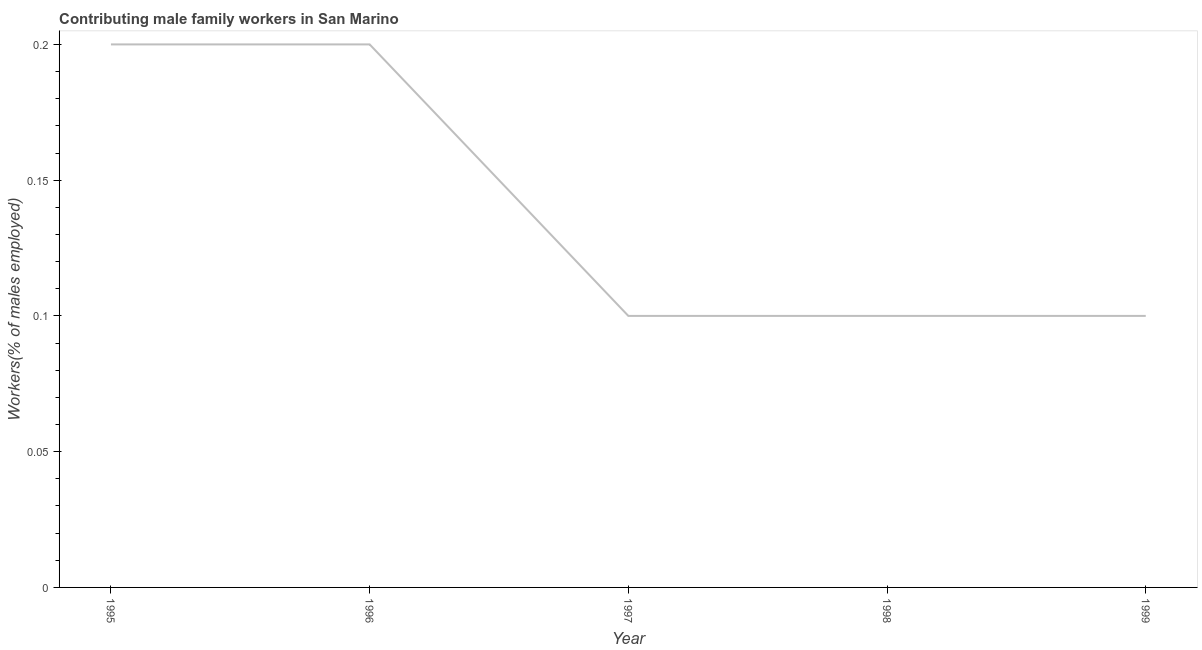What is the contributing male family workers in 1996?
Offer a very short reply. 0.2. Across all years, what is the maximum contributing male family workers?
Provide a succinct answer. 0.2. Across all years, what is the minimum contributing male family workers?
Ensure brevity in your answer.  0.1. What is the sum of the contributing male family workers?
Your answer should be very brief. 0.7. What is the difference between the contributing male family workers in 1995 and 1999?
Make the answer very short. 0.1. What is the average contributing male family workers per year?
Provide a succinct answer. 0.14. What is the median contributing male family workers?
Provide a succinct answer. 0.1. Do a majority of the years between 1996 and 1997 (inclusive) have contributing male family workers greater than 0.12000000000000001 %?
Offer a very short reply. No. What is the ratio of the contributing male family workers in 1996 to that in 1999?
Make the answer very short. 2. Is the contributing male family workers in 1995 less than that in 1997?
Provide a succinct answer. No. Is the difference between the contributing male family workers in 1996 and 1997 greater than the difference between any two years?
Ensure brevity in your answer.  Yes. What is the difference between the highest and the second highest contributing male family workers?
Provide a short and direct response. 0. What is the difference between the highest and the lowest contributing male family workers?
Provide a short and direct response. 0.1. How many lines are there?
Give a very brief answer. 1. How many years are there in the graph?
Your answer should be compact. 5. What is the difference between two consecutive major ticks on the Y-axis?
Your response must be concise. 0.05. What is the title of the graph?
Offer a very short reply. Contributing male family workers in San Marino. What is the label or title of the X-axis?
Offer a very short reply. Year. What is the label or title of the Y-axis?
Provide a short and direct response. Workers(% of males employed). What is the Workers(% of males employed) in 1995?
Your response must be concise. 0.2. What is the Workers(% of males employed) in 1996?
Keep it short and to the point. 0.2. What is the Workers(% of males employed) in 1997?
Ensure brevity in your answer.  0.1. What is the Workers(% of males employed) of 1998?
Provide a short and direct response. 0.1. What is the Workers(% of males employed) of 1999?
Ensure brevity in your answer.  0.1. What is the difference between the Workers(% of males employed) in 1995 and 1997?
Your answer should be very brief. 0.1. What is the ratio of the Workers(% of males employed) in 1995 to that in 1997?
Offer a terse response. 2. What is the ratio of the Workers(% of males employed) in 1995 to that in 1998?
Your answer should be compact. 2. What is the ratio of the Workers(% of males employed) in 1996 to that in 1997?
Offer a very short reply. 2. What is the ratio of the Workers(% of males employed) in 1997 to that in 1999?
Offer a terse response. 1. What is the ratio of the Workers(% of males employed) in 1998 to that in 1999?
Give a very brief answer. 1. 